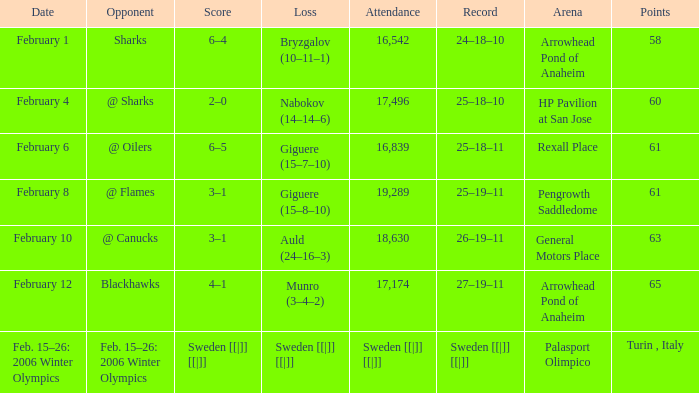What is the record when the score was 2–0? 25–18–10. 